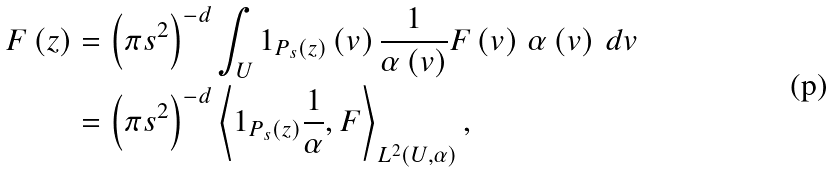Convert formula to latex. <formula><loc_0><loc_0><loc_500><loc_500>F \left ( z \right ) & = \left ( \pi s ^ { 2 } \right ) ^ { - d } \int _ { U } 1 _ { P _ { s } \left ( z \right ) } \left ( v \right ) \frac { 1 } { \alpha \left ( v \right ) } F \left ( v \right ) \, \alpha \left ( v \right ) \, d v \\ & = \left ( \pi s ^ { 2 } \right ) ^ { - d } \left \langle 1 _ { P _ { s } \left ( z \right ) } \frac { 1 } { \alpha } , F \right \rangle _ { L ^ { 2 } \left ( U , \alpha \right ) } ,</formula> 